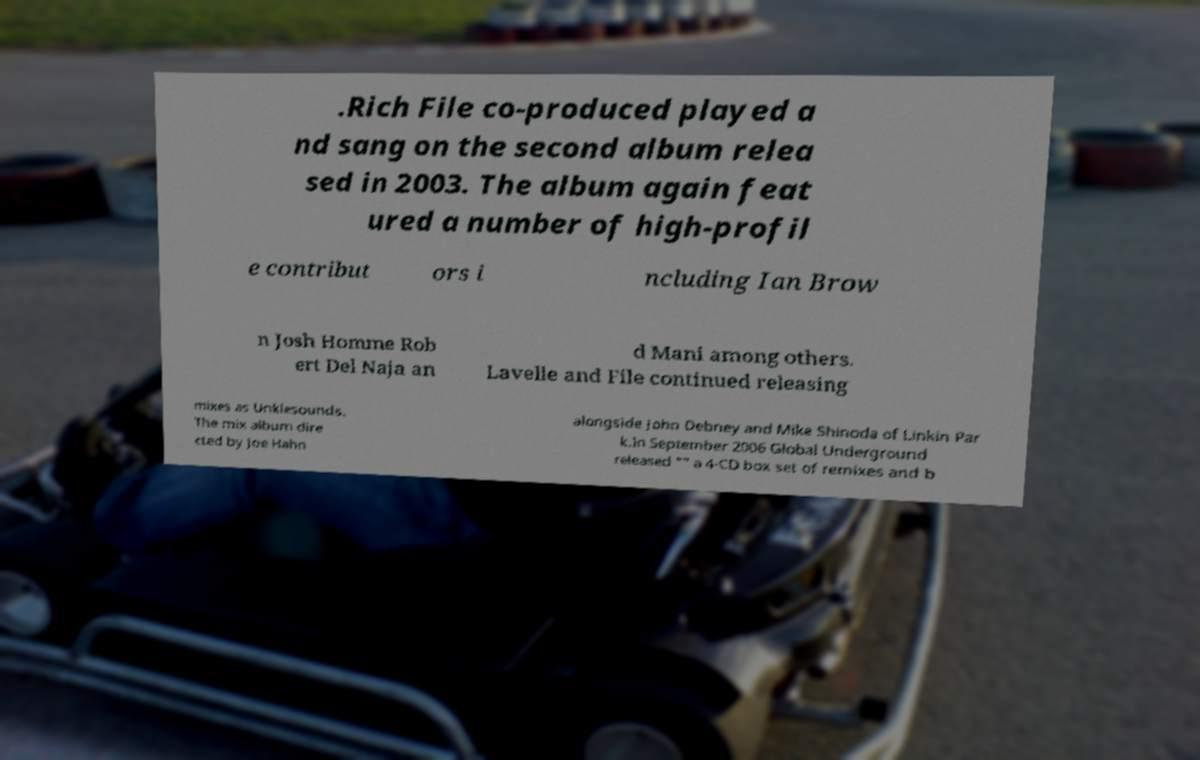Could you assist in decoding the text presented in this image and type it out clearly? .Rich File co-produced played a nd sang on the second album relea sed in 2003. The album again feat ured a number of high-profil e contribut ors i ncluding Ian Brow n Josh Homme Rob ert Del Naja an d Mani among others. Lavelle and File continued releasing mixes as Unklesounds. The mix album dire cted by Joe Hahn alongside John Debney and Mike Shinoda of Linkin Par k.In September 2006 Global Underground released "" a 4-CD box set of remixes and b 